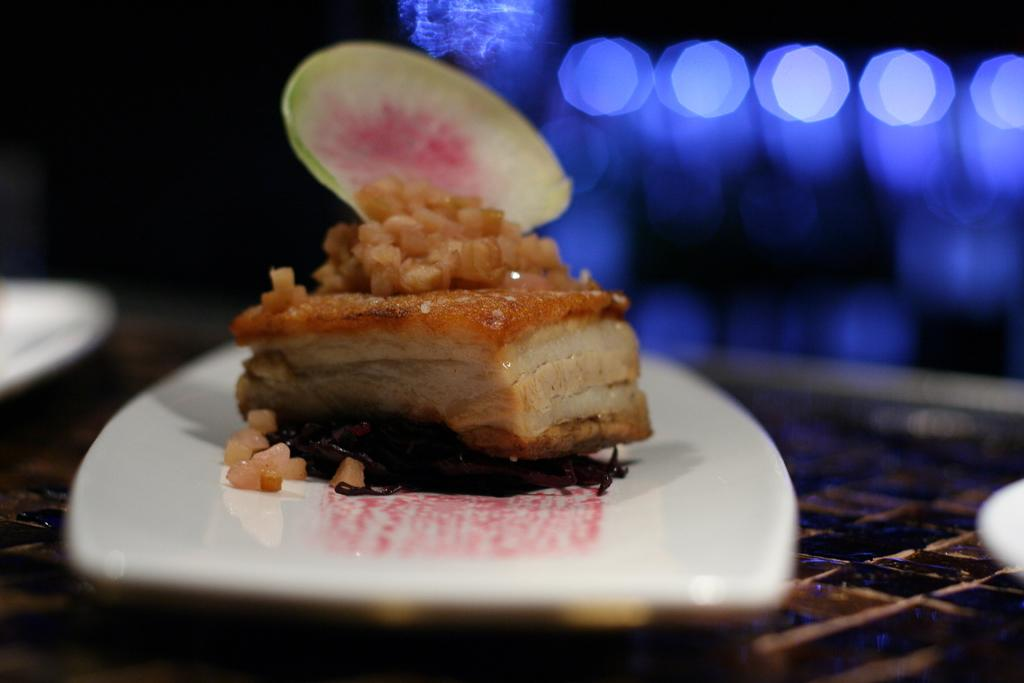What piece of furniture is present in the image? There is a table in the image. What items are placed on the table? There are plates and a dish on the table. Can you describe the background of the image? The background of the image is blurred. How many deer can be seen in the image? There are no deer present in the image. What type of cakes are being served on the plates in the image? The image does not show any cakes on the plates, only plates and a dish. Is there a pear on the table in the image? There is no pear visible on the table in the image. 